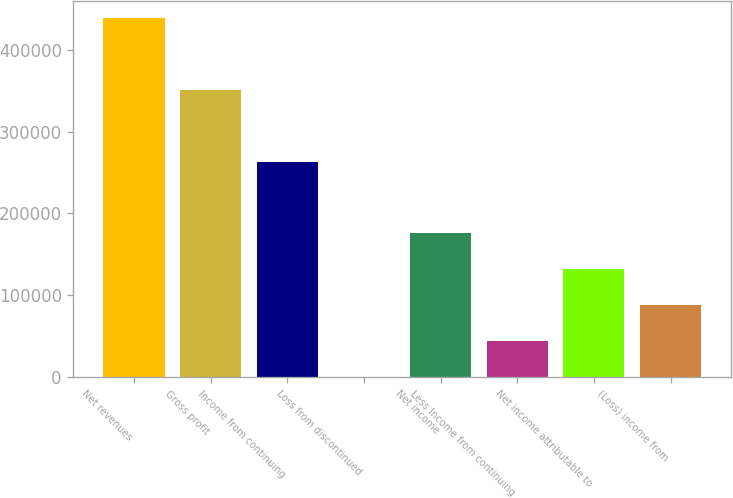Convert chart to OTSL. <chart><loc_0><loc_0><loc_500><loc_500><bar_chart><fcel>Net revenues<fcel>Gross profit<fcel>Income from continuing<fcel>Loss from discontinued<fcel>Net income<fcel>Less Income from continuing<fcel>Net income attributable to<fcel>(Loss) income from<nl><fcel>438546<fcel>350862<fcel>263178<fcel>125<fcel>175493<fcel>43967.1<fcel>131651<fcel>87809.2<nl></chart> 